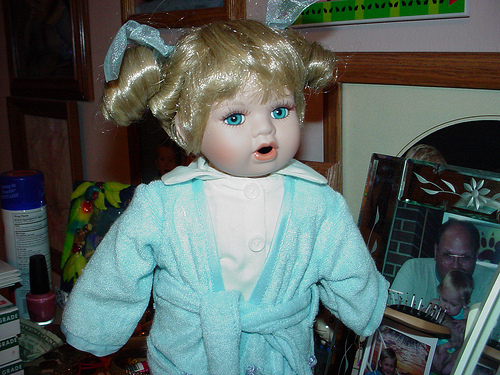<image>
Can you confirm if the doll is next to the nail polish? Yes. The doll is positioned adjacent to the nail polish, located nearby in the same general area. 